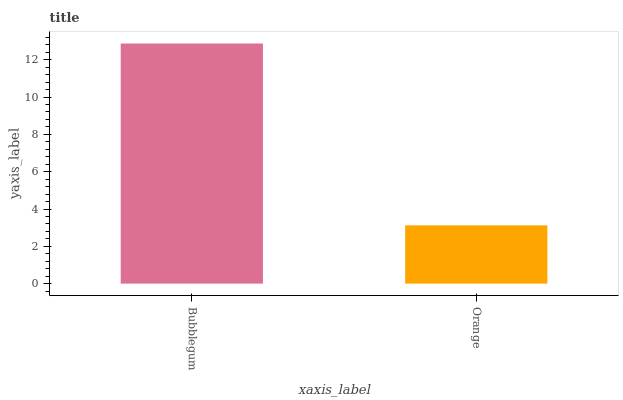Is Orange the minimum?
Answer yes or no. Yes. Is Bubblegum the maximum?
Answer yes or no. Yes. Is Orange the maximum?
Answer yes or no. No. Is Bubblegum greater than Orange?
Answer yes or no. Yes. Is Orange less than Bubblegum?
Answer yes or no. Yes. Is Orange greater than Bubblegum?
Answer yes or no. No. Is Bubblegum less than Orange?
Answer yes or no. No. Is Bubblegum the high median?
Answer yes or no. Yes. Is Orange the low median?
Answer yes or no. Yes. Is Orange the high median?
Answer yes or no. No. Is Bubblegum the low median?
Answer yes or no. No. 